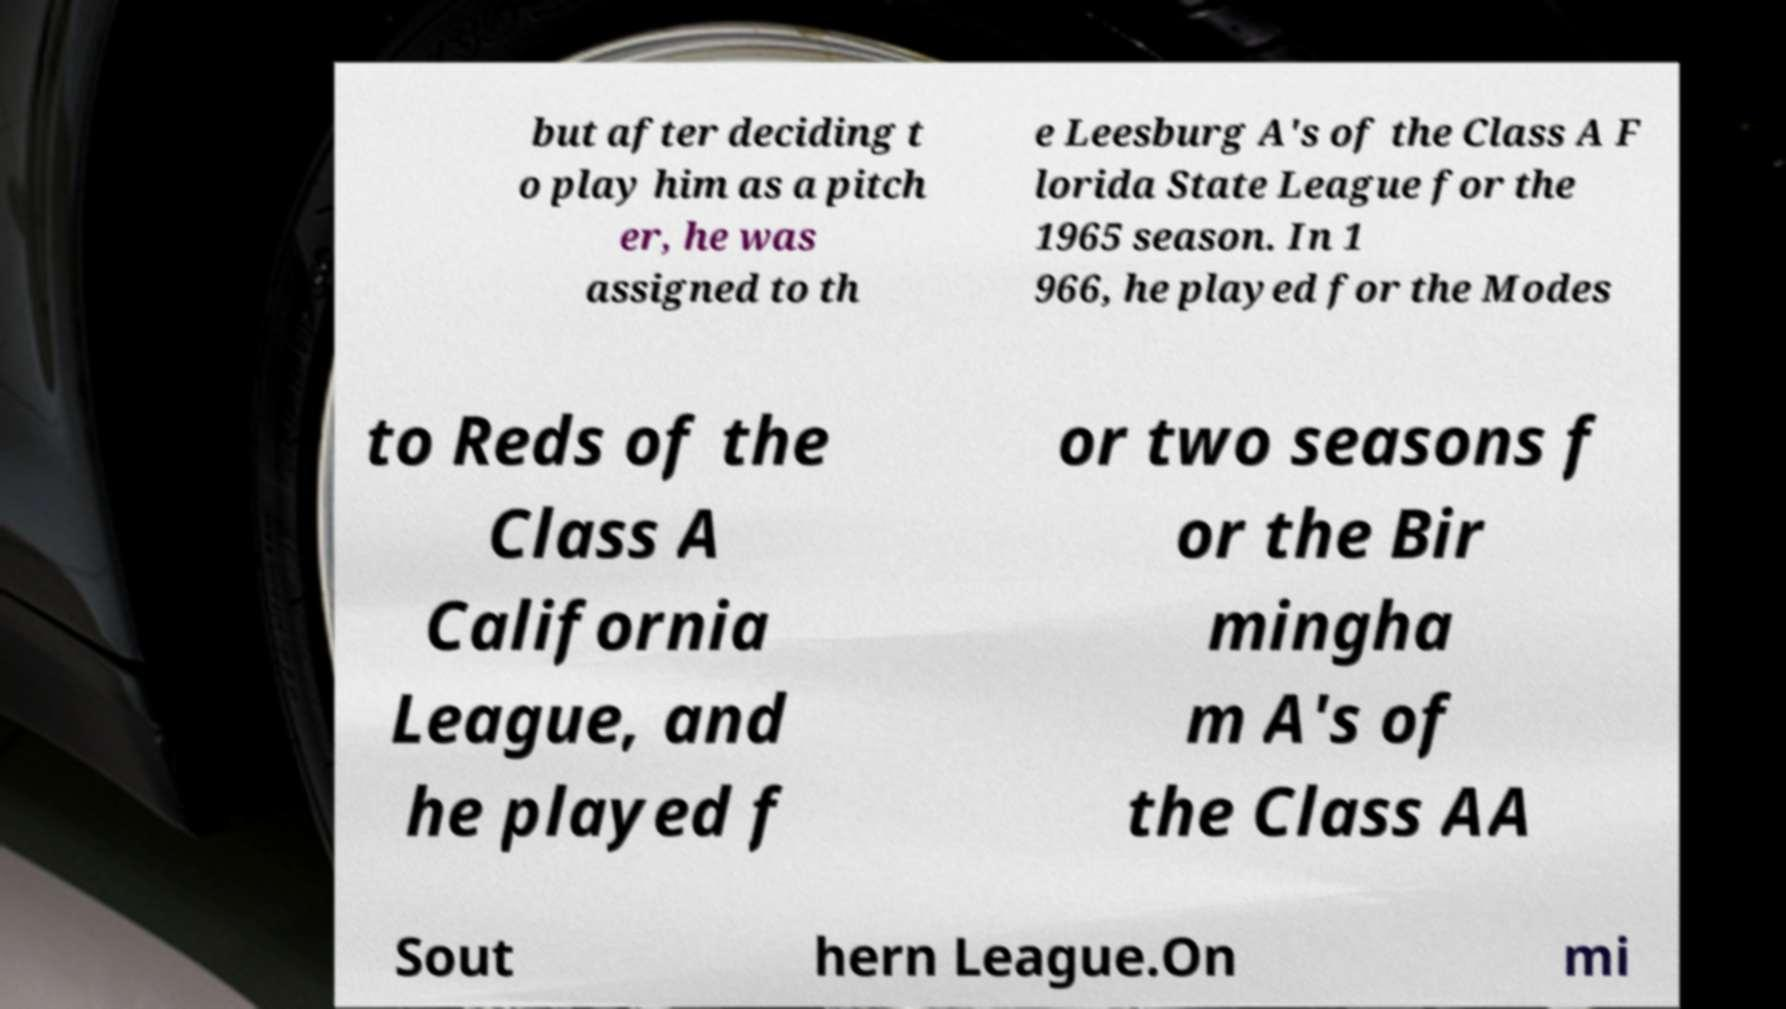Could you assist in decoding the text presented in this image and type it out clearly? but after deciding t o play him as a pitch er, he was assigned to th e Leesburg A's of the Class A F lorida State League for the 1965 season. In 1 966, he played for the Modes to Reds of the Class A California League, and he played f or two seasons f or the Bir mingha m A's of the Class AA Sout hern League.On mi 